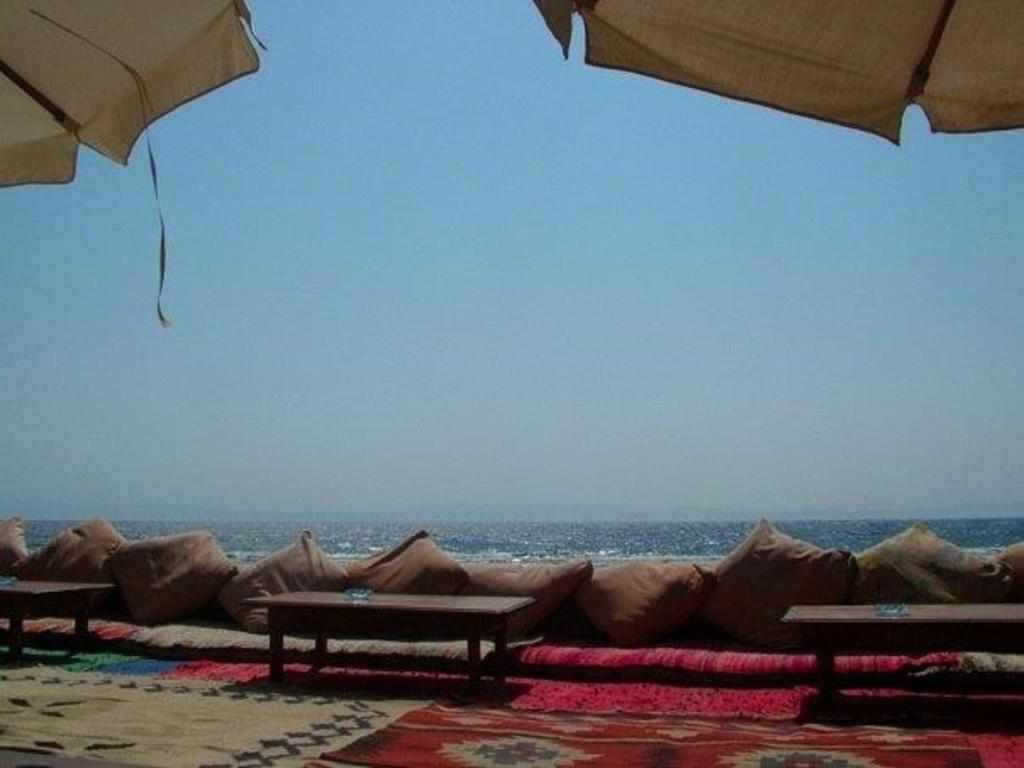What type of shelter is visible in the image? There is a tent in the image. What type of furniture is present in the image? There are tables in the image. What type of soft furnishings are present in the image? There are pillows in the image. What can be seen in the background of the image? The sky is visible in the background of the image. What type of meat is being cooked on the edge of the tent in the image? There is no meat or cooking activity present in the image; it only features a tent, tables, pillows, and the sky in the background. 